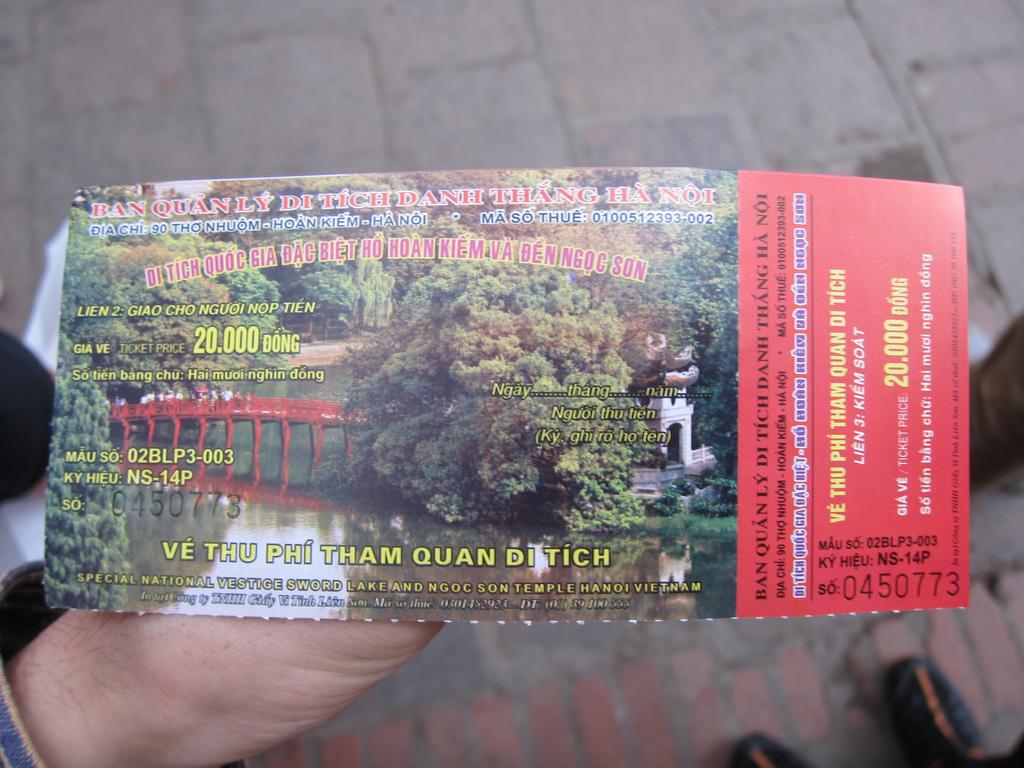What colour is the bridge?
Make the answer very short. Answering does not require reading text in the image. Whats the ticket number on the nottom right?
Your response must be concise. 0450773. 